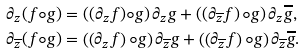Convert formula to latex. <formula><loc_0><loc_0><loc_500><loc_500>\partial _ { z } ( f \circ g ) & = \left ( ( \partial _ { z } f ) \circ g \right ) \partial _ { z } g + \left ( \left ( \partial _ { \overline { z } } f \right ) \circ g \right ) \partial _ { z } \overline { g } , \\ \partial _ { \overline { z } } ( f \circ g ) & = \left ( \left ( \partial _ { z } f \right ) \circ g \right ) \partial _ { \overline { z } } g + \left ( \left ( \partial _ { \overline { z } } f \right ) \circ g \right ) \partial _ { \overline { z } } \overline { g } .</formula> 